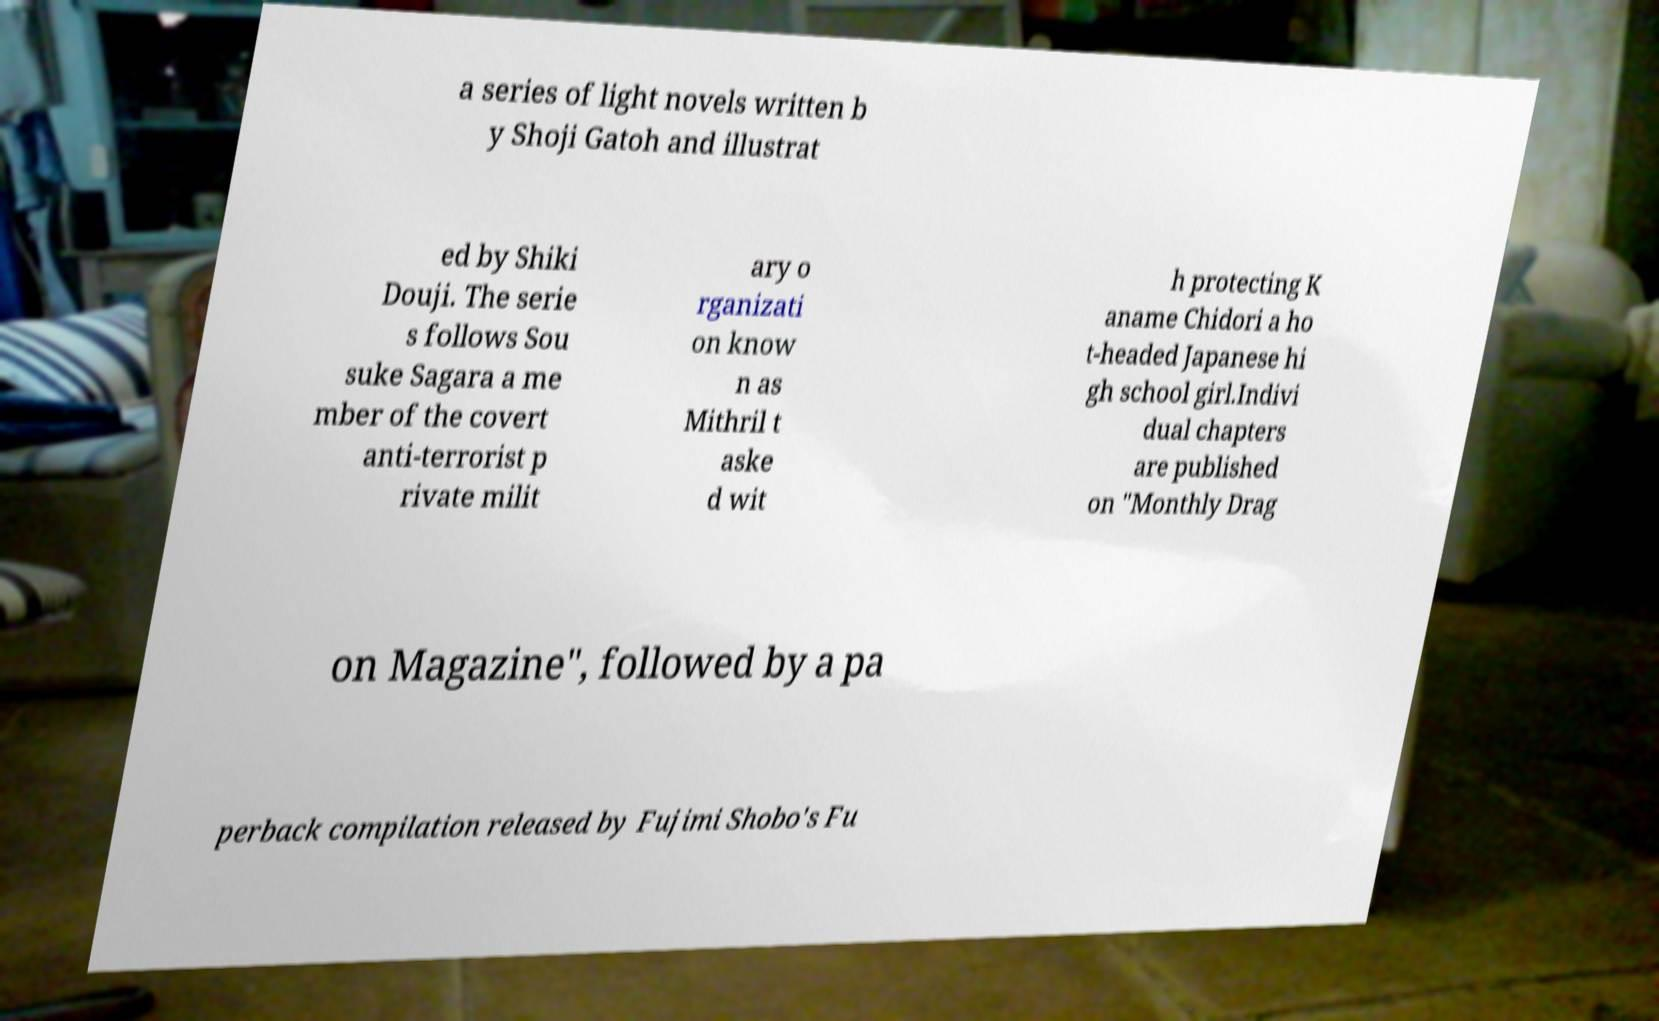Can you accurately transcribe the text from the provided image for me? a series of light novels written b y Shoji Gatoh and illustrat ed by Shiki Douji. The serie s follows Sou suke Sagara a me mber of the covert anti-terrorist p rivate milit ary o rganizati on know n as Mithril t aske d wit h protecting K aname Chidori a ho t-headed Japanese hi gh school girl.Indivi dual chapters are published on "Monthly Drag on Magazine", followed by a pa perback compilation released by Fujimi Shobo's Fu 